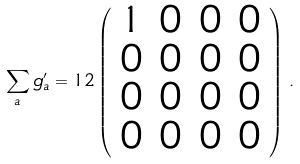<formula> <loc_0><loc_0><loc_500><loc_500>\sum _ { a } g ^ { \prime } _ { a } = 1 2 \left ( \begin{array} { r r r r } 1 & 0 & 0 & 0 \\ 0 & 0 & 0 & 0 \\ 0 & 0 & 0 & 0 \\ 0 & 0 & 0 & 0 \end{array} \right ) \, .</formula> 